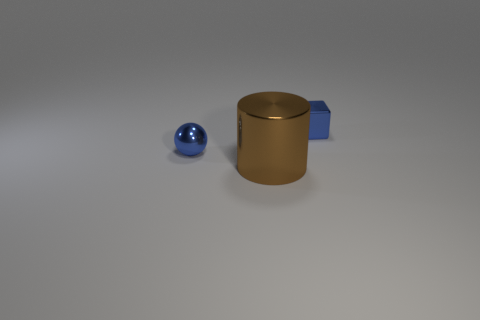Add 3 matte objects. How many objects exist? 6 Subtract all cylinders. How many objects are left? 2 Add 3 large brown cylinders. How many large brown cylinders are left? 4 Add 1 brown cylinders. How many brown cylinders exist? 2 Subtract 0 yellow cylinders. How many objects are left? 3 Subtract all small blue shiny blocks. Subtract all blue metallic objects. How many objects are left? 0 